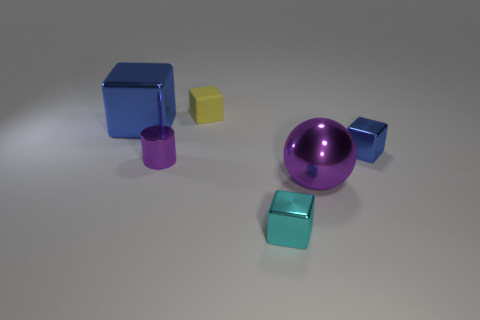Subtract 1 cubes. How many cubes are left? 3 Add 1 large blue matte spheres. How many objects exist? 7 Subtract all cubes. How many objects are left? 2 Subtract 0 gray spheres. How many objects are left? 6 Subtract all metal things. Subtract all big purple metallic cubes. How many objects are left? 1 Add 3 small cyan metallic objects. How many small cyan metallic objects are left? 4 Add 3 tiny cyan metal cylinders. How many tiny cyan metal cylinders exist? 3 